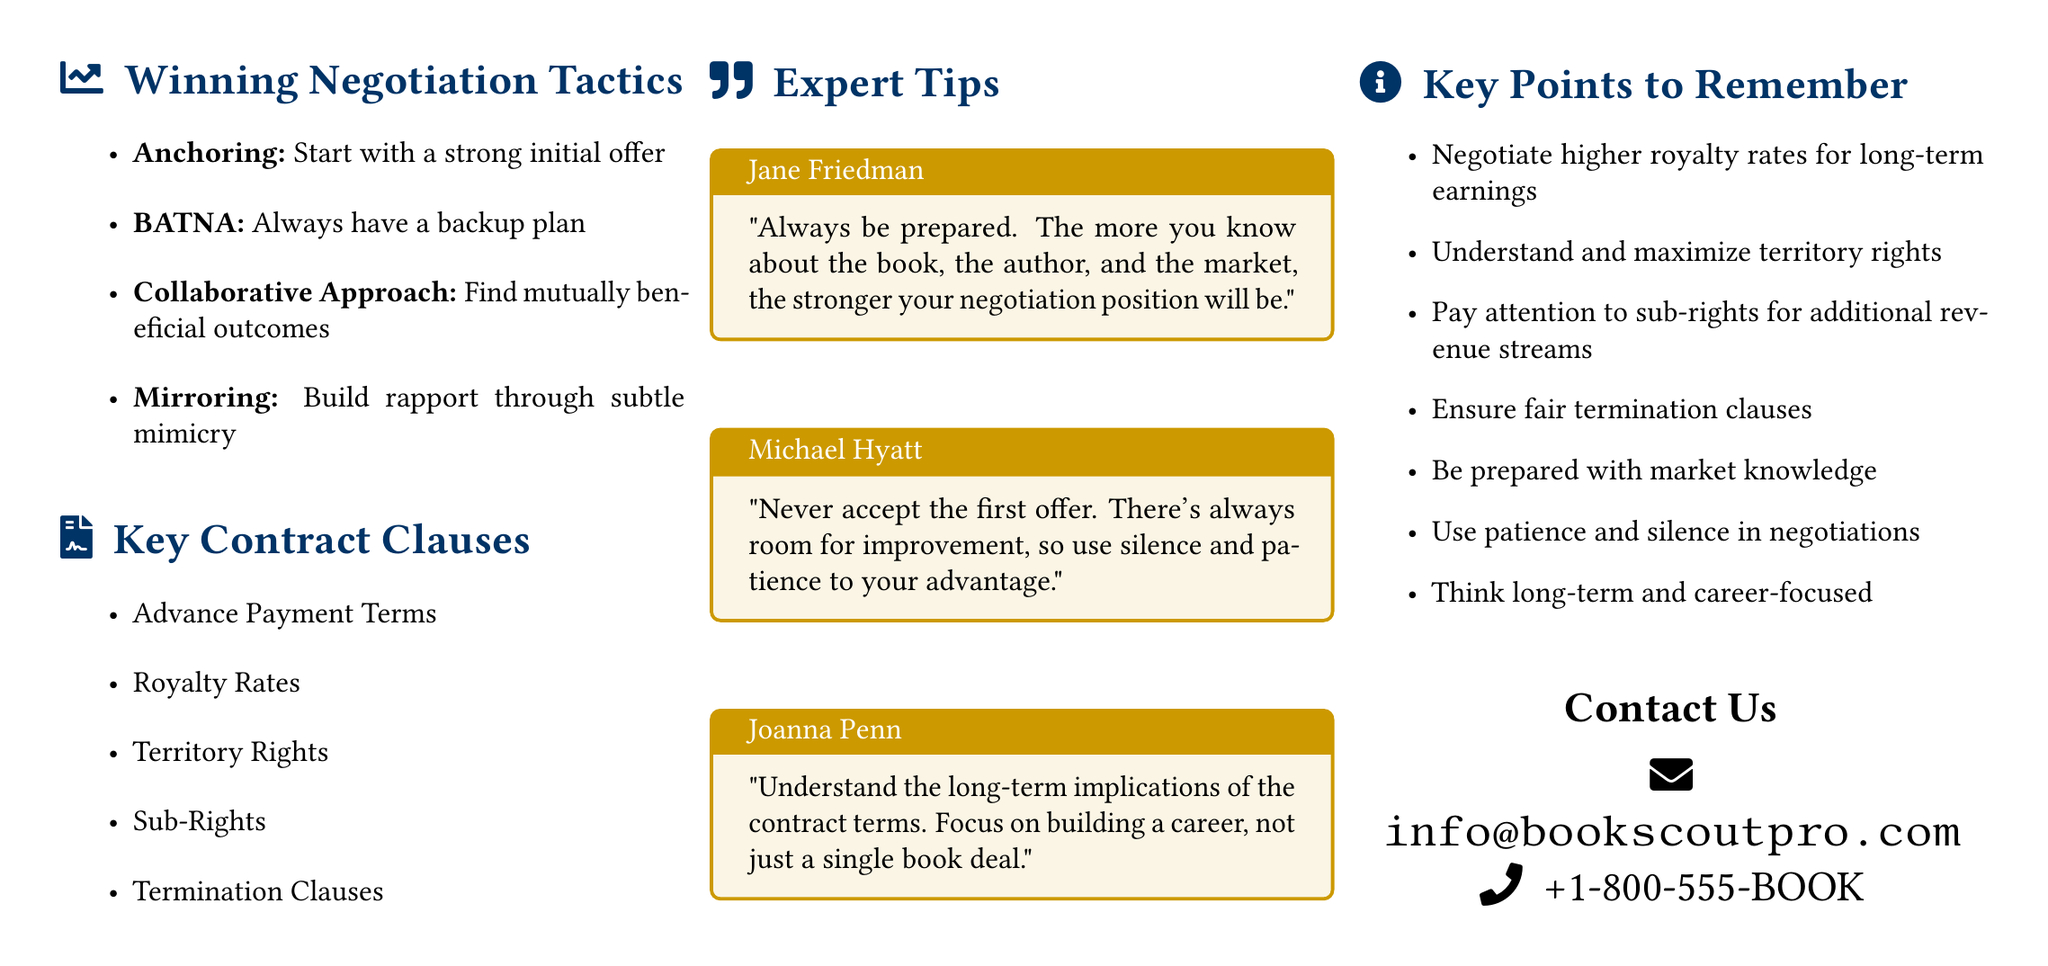What are winning negotiation tactics mentioned? The document lists specific tactics under the section "Winning Negotiation Tactics."
Answer: Anchoring, BATNA, Collaborative Approach, Mirroring How many experts provided tips in the document? The section "Expert Tips" contains quotes from three industry experts.
Answer: Three What key contract clause is related to payments? The document lists "Advance Payment Terms" as a key contract clause regarding payments.
Answer: Advance Payment Terms Who is the first expert quoted in the tips? The document provides quotes from multiple experts, with Jane Friedman being the first.
Answer: Jane Friedman What is the main color used in the document design? The document specifies a main color for headings and sections, identified in RGB.
Answer: RGB(0,51,102) What should you focus on according to Joanna Penn’s tip? Joanna Penn emphasizes the importance of long-term implications in contract terms.
Answer: Building a career What contact method is provided in the document? The document includes contact information, specifically for email and phone.
Answer: Email and phone Which clause should be ensured according to key points? The document highlights the necessity of fair termination clauses within contract negotiations.
Answer: Fair termination clauses 